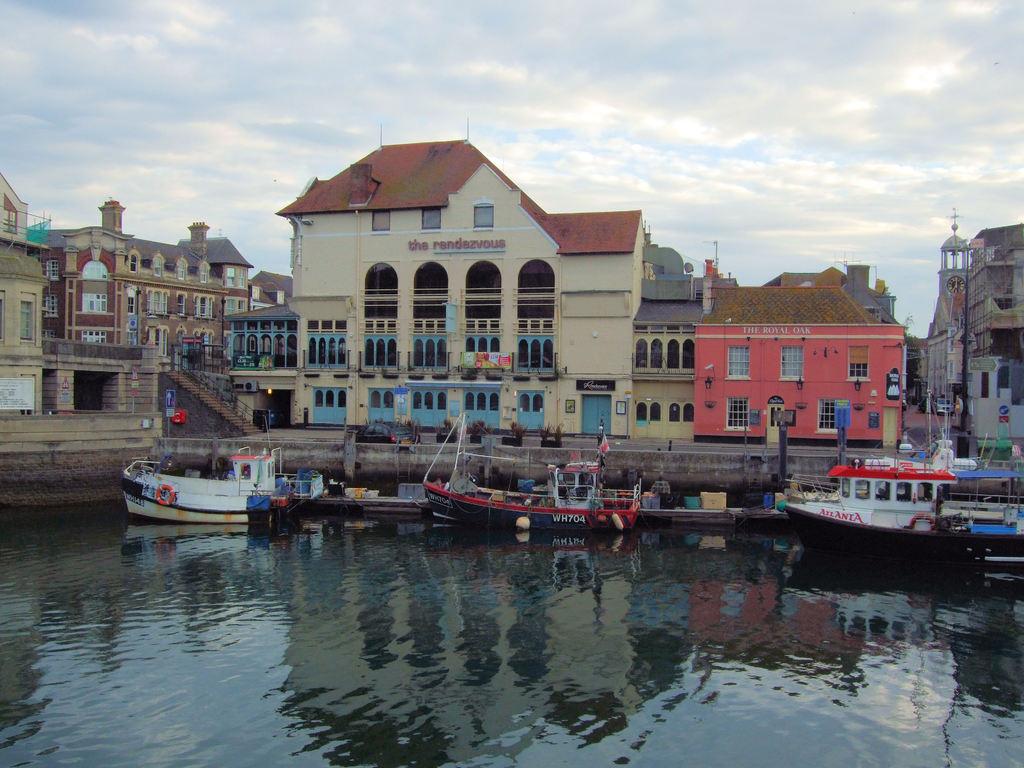What number is the boat in the middle?
Offer a very short reply. Wh704. What is the building called in the middle?
Your answer should be very brief. The rendezvous. 